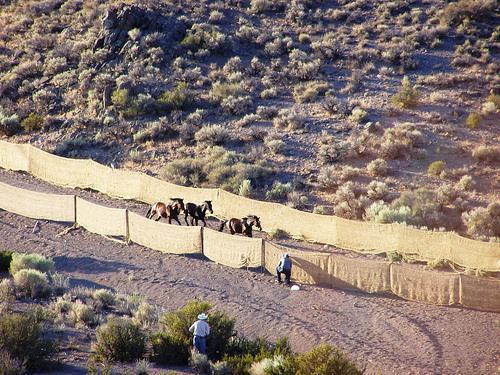How many cowboys are there?
Give a very brief answer. 2. 